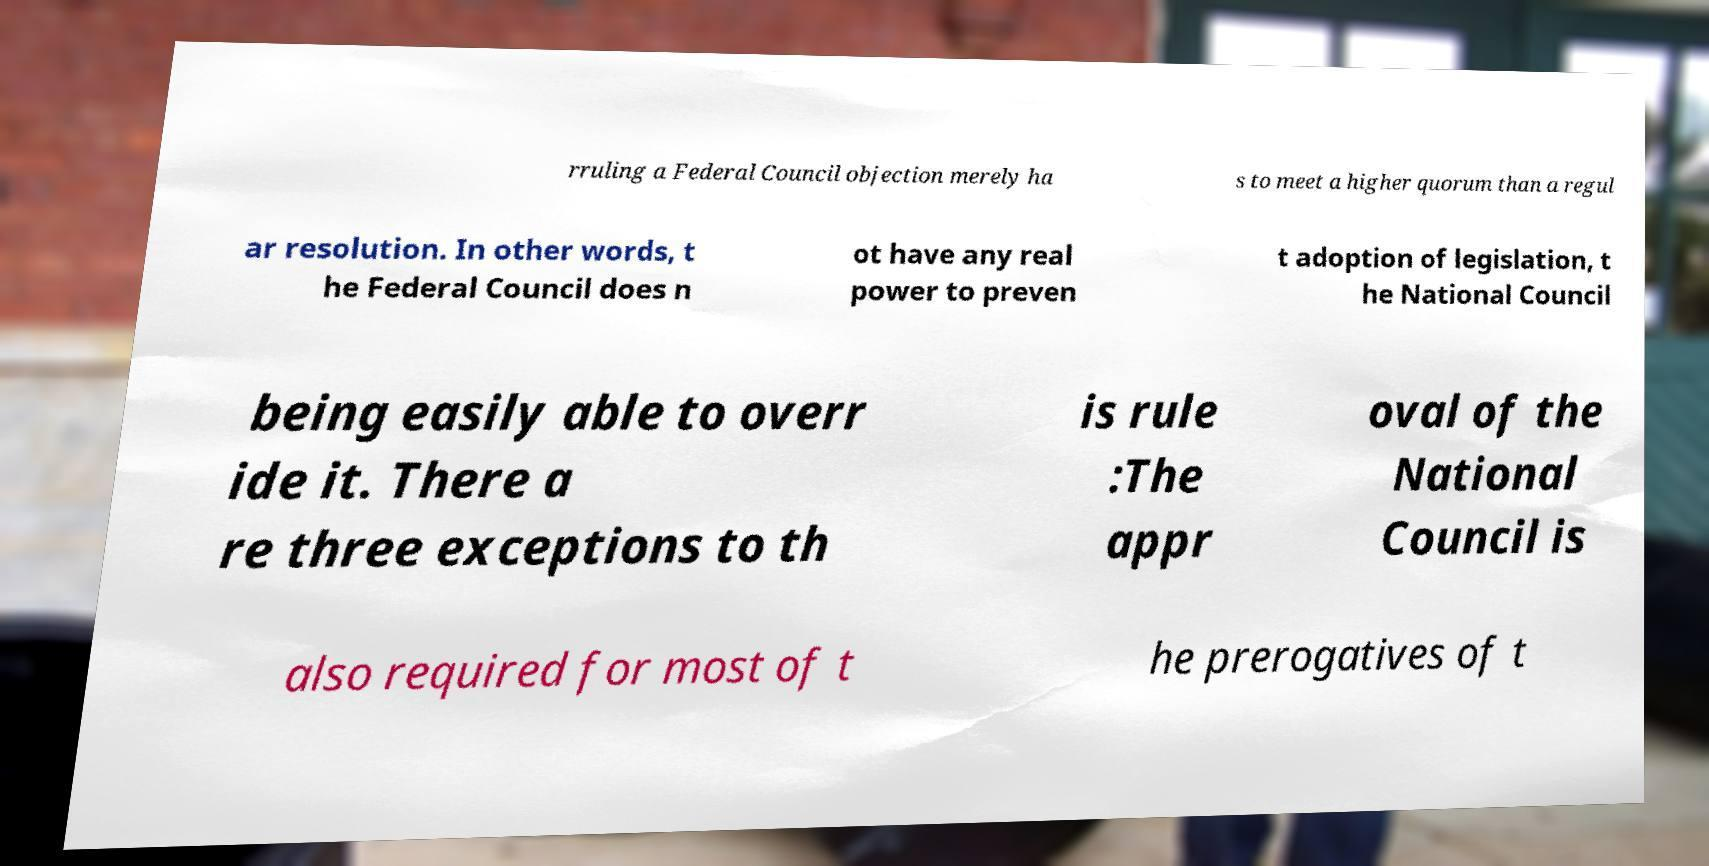For documentation purposes, I need the text within this image transcribed. Could you provide that? rruling a Federal Council objection merely ha s to meet a higher quorum than a regul ar resolution. In other words, t he Federal Council does n ot have any real power to preven t adoption of legislation, t he National Council being easily able to overr ide it. There a re three exceptions to th is rule :The appr oval of the National Council is also required for most of t he prerogatives of t 